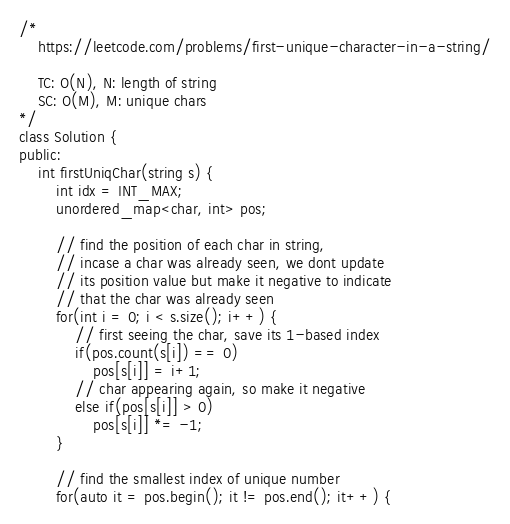Convert code to text. <code><loc_0><loc_0><loc_500><loc_500><_C++_>/*
    https://leetcode.com/problems/first-unique-character-in-a-string/
    
    TC: O(N), N: length of string
    SC: O(M), M: unique chars
*/
class Solution {
public:
    int firstUniqChar(string s) {
        int idx = INT_MAX;
        unordered_map<char, int> pos;
        
        // find the position of each char in string,
        // incase a char was already seen, we dont update
        // its position value but make it negative to indicate
        // that the char was already seen
        for(int i = 0; i < s.size(); i++) {
            // first seeing the char, save its 1-based index
            if(pos.count(s[i]) == 0)
                pos[s[i]] = i+1;
            // char appearing again, so make it negative
            else if(pos[s[i]] > 0)
                pos[s[i]] *= -1;
        }
        
        // find the smallest index of unique number
        for(auto it = pos.begin(); it != pos.end(); it++) {</code> 